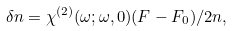<formula> <loc_0><loc_0><loc_500><loc_500>\delta n = \chi ^ { ( 2 ) } ( \omega ; \omega , 0 ) ( F - F _ { 0 } ) / 2 n ,</formula> 